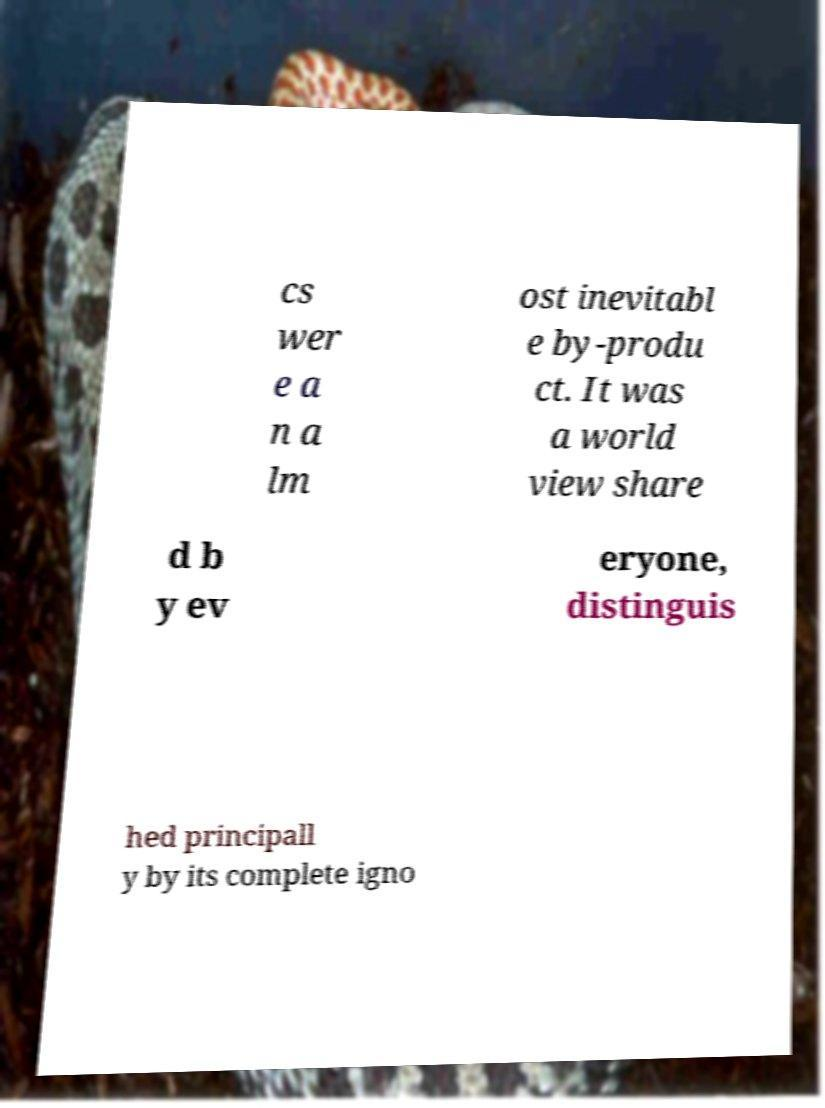What messages or text are displayed in this image? I need them in a readable, typed format. cs wer e a n a lm ost inevitabl e by-produ ct. It was a world view share d b y ev eryone, distinguis hed principall y by its complete igno 